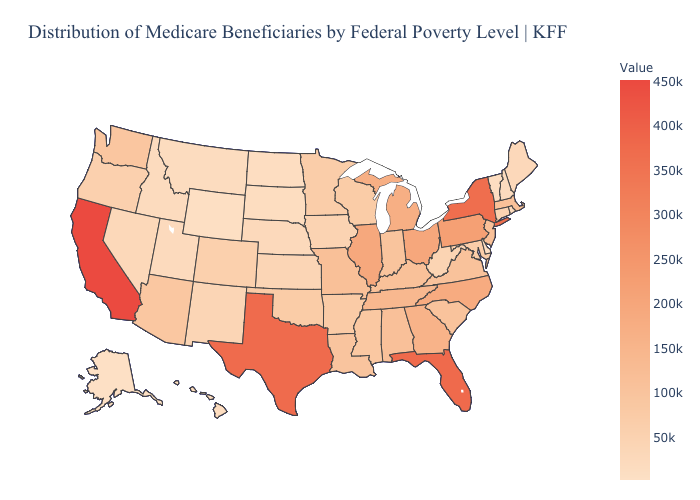Which states hav the highest value in the South?
Give a very brief answer. Florida. Which states have the lowest value in the USA?
Write a very short answer. Alaska. Does Nebraska have the highest value in the USA?
Keep it brief. No. Does the map have missing data?
Keep it brief. No. Which states have the highest value in the USA?
Write a very short answer. California. Does Minnesota have the highest value in the MidWest?
Be succinct. No. Among the states that border Virginia , which have the lowest value?
Answer briefly. West Virginia. 